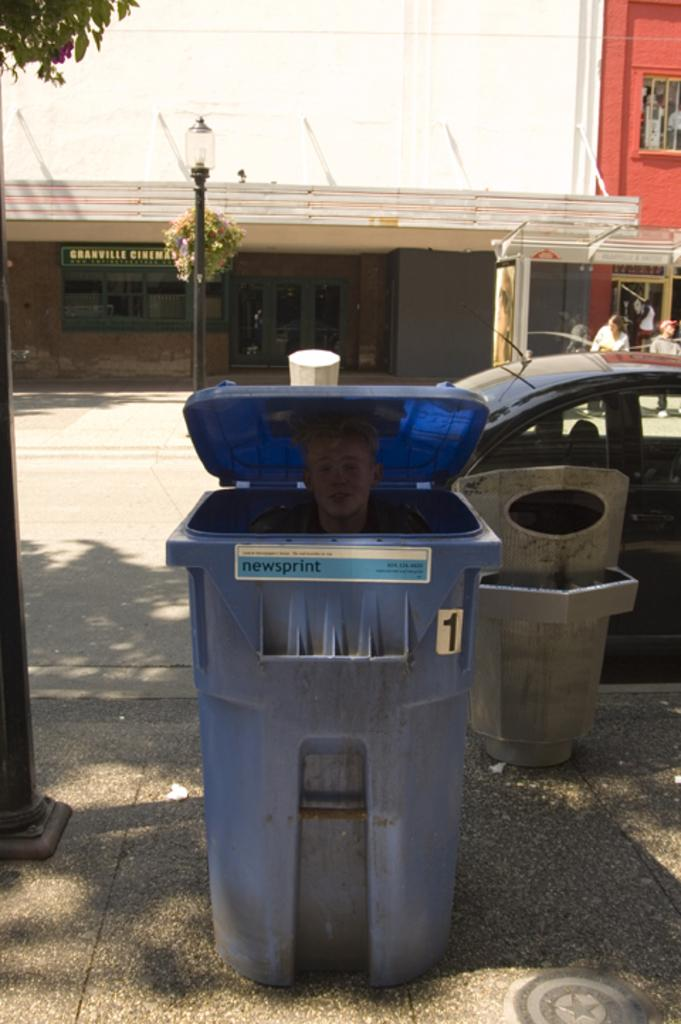<image>
Write a terse but informative summary of the picture. A person in a blue bin marked 1 that says newsprint. 